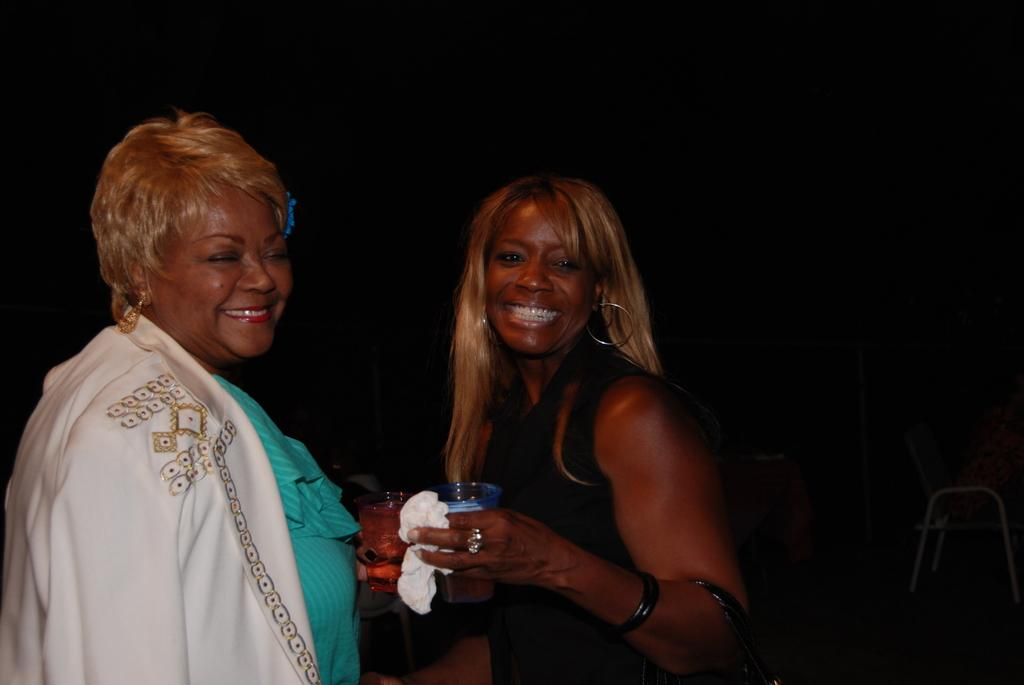How many people are in the image? There are two women in the image. What are the women doing in the image? The women are standing and smiling. What are the women holding in their hands? Both women are holding glasses in their hands. What is the color of the background in the image? The background of the image is black. What type of income can be seen in the image? There is no reference to income in the image; it features two women standing and smiling while holding glasses. What kind of lunch is being served in the image? There is no lunch or food visible in the image. 